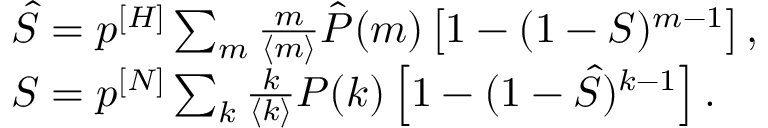<formula> <loc_0><loc_0><loc_500><loc_500>\begin{array} { l } { \hat { S } = p ^ { [ H ] } \sum _ { m } \frac { m } { \langle m \rangle } \hat { P } ( m ) \left [ 1 - ( 1 - S ) ^ { m - 1 } \right ] , } \\ { S = p ^ { [ N ] } \sum _ { k } \frac { k } { \langle k \rangle } P ( k ) \left [ 1 - ( 1 - \hat { S } ) ^ { k - 1 } \right ] . } \end{array}</formula> 